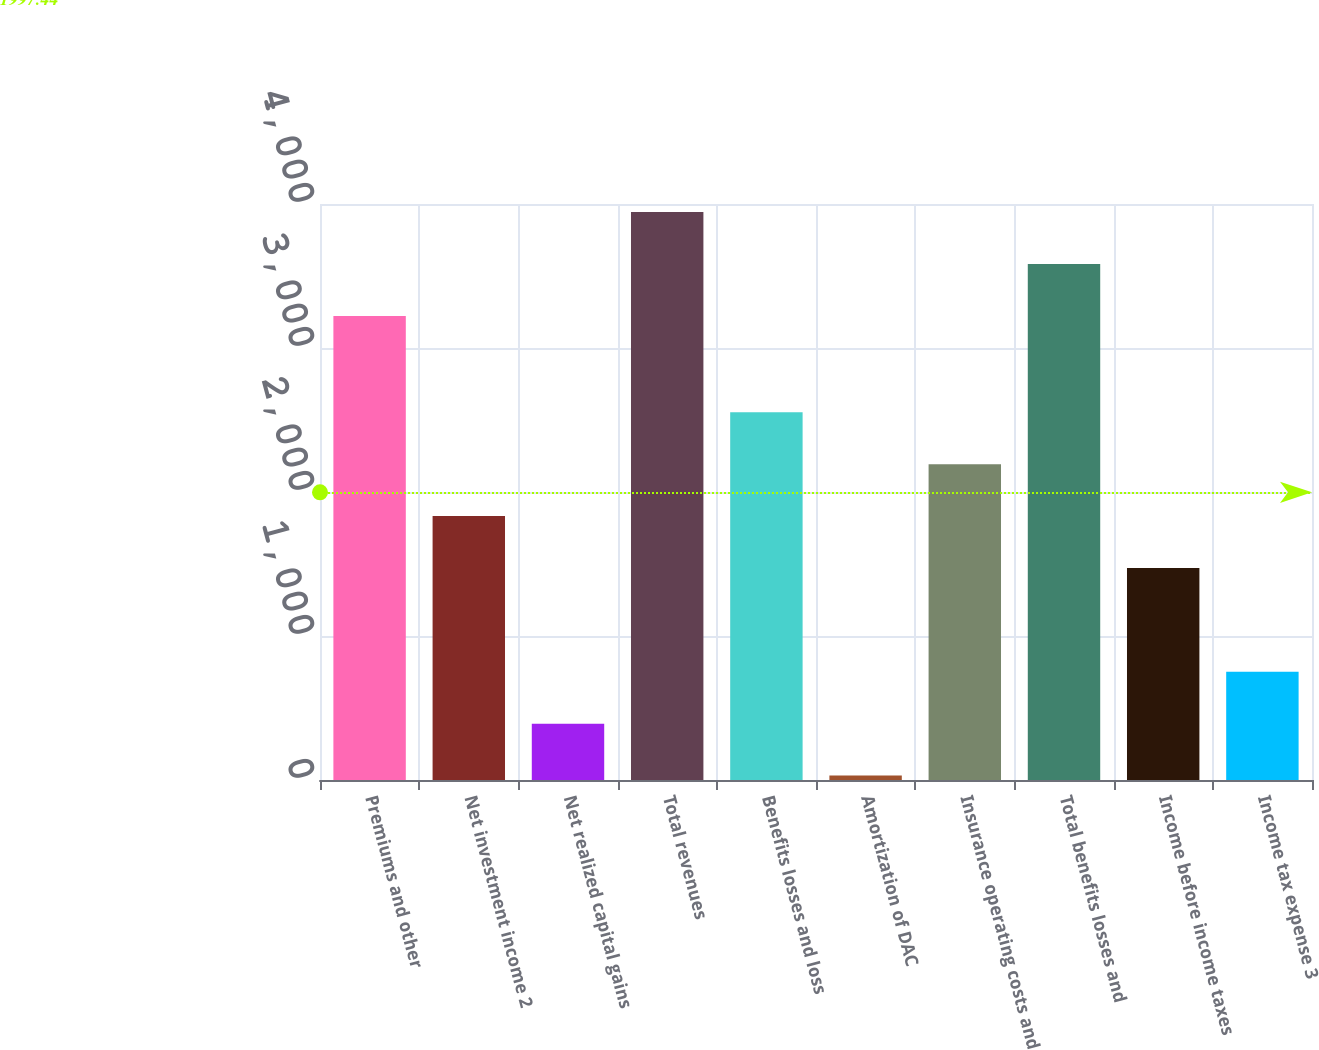<chart> <loc_0><loc_0><loc_500><loc_500><bar_chart><fcel>Premiums and other<fcel>Net investment income 2<fcel>Net realized capital gains<fcel>Total revenues<fcel>Benefits losses and loss<fcel>Amortization of DAC<fcel>Insurance operating costs and<fcel>Total benefits losses and<fcel>Income before income taxes<fcel>Income tax expense 3<nl><fcel>3223<fcel>1832.5<fcel>391.3<fcel>3943.6<fcel>2553.1<fcel>31<fcel>2192.8<fcel>3583.3<fcel>1472.2<fcel>751.6<nl></chart> 